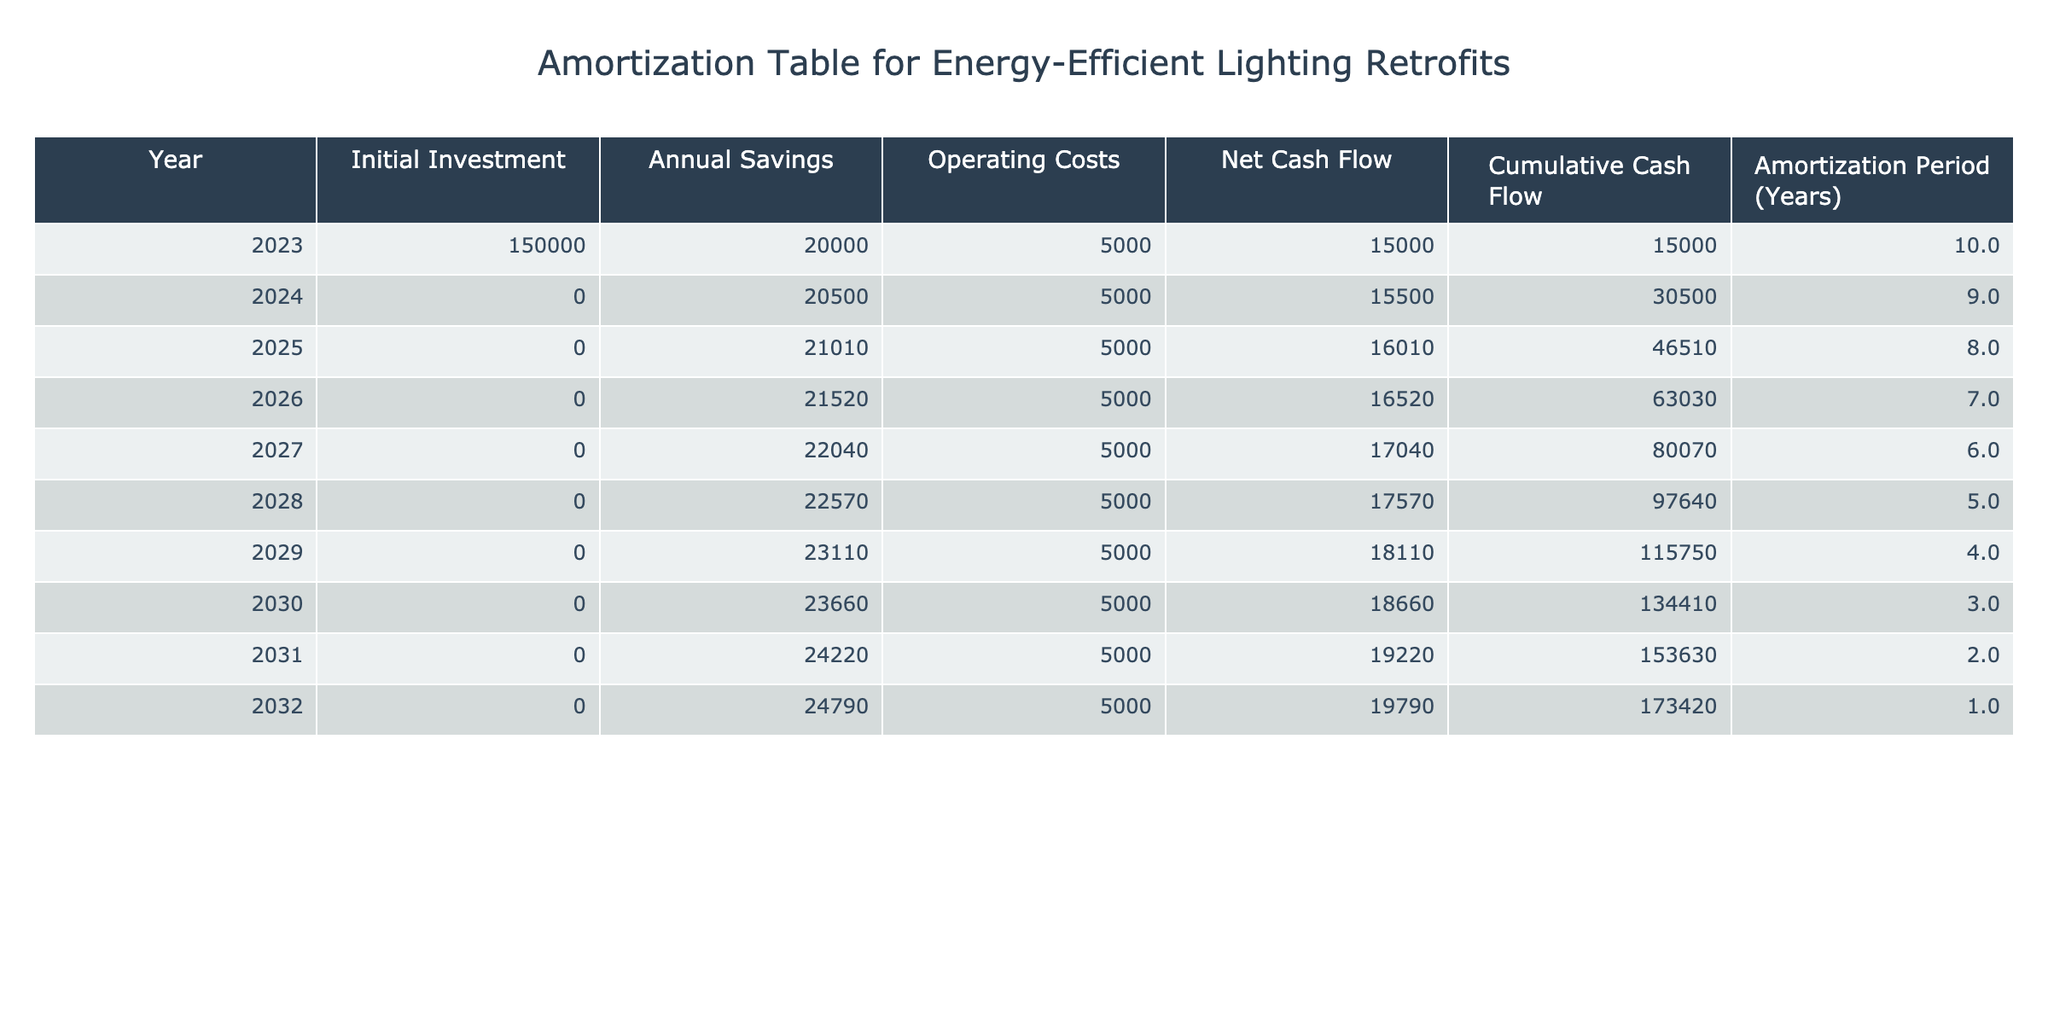What is the initial investment for the energy-efficient lighting retrofits? The initial investment is listed in the first row under the "Initial Investment" column, which shows an amount of $150,000 for the year 2023.
Answer: 150000 What is the annual savings in 2026? The annual savings for the year 2026 can be found in the corresponding row under the "Annual Savings" column, which indicates $21,520.
Answer: 21520 What is the cumulative cash flow by the end of 2029? To find the cumulative cash flow for 2029, we look at the "Cumulative Cash Flow" column. In 2029, it shows a total of $115,750.
Answer: 115750 What is the average annual savings over the years 2023 to 2026? The annual savings from 2023 to 2026 are $20,000, $20,500, $21,010, and $21,520. First, calculate the total: 20000 + 20500 + 21010 + 21520 = 85030. Then, divide by 4 (the number of years): 85030 / 4 = 21257.5.
Answer: 21257.5 Does the net cash flow increase every year? To determine this, we need to look at the "Net Cash Flow" column for each year. The net cash flow is $15,000 in 2023, $15,500 in 2024, $16,010 in 2025, and continues to increase until $19,790 in 2032. Thus, the net cash flow does increase every year.
Answer: Yes What is the difference in cumulative cash flow between 2025 and 2027? We locate the cumulative cash flow in 2025 ($46,510) and in 2027 ($80,070). The difference is calculated as $80,070 - $46,510 = $33,560.
Answer: 33560 What is the total net cash flow from 2023 to 2032? The net cash flows from 2023 to 2032 are $15,000, $15,500, $16,010, $16,520, $17,040, $17,570, $18,110, $18,660, $19,220, and $19,790. First, sum these values: 15000 + 15500 + 16010 + 16520 + 17040 + 17570 + 18110 + 18660 + 19220 + 19790 = $178,520.
Answer: 178520 Is the operating cost consistent every year? By examining the "Operating Costs" column, it shows a constant $5,000 for each year from 2023 to 2032. Therefore, the operating cost is consistent each year.
Answer: Yes What is the total net cash flow over the entire amortization period? The total net cash flows over the years, which is the sum of each year's net cash flow. Adding each value: 15000 + 15500 + 16010 + 16520 + 17040 + 17570 + 18110 + 18660 + 19220 + 19790 = $178,520 confirms the total.
Answer: 178520 